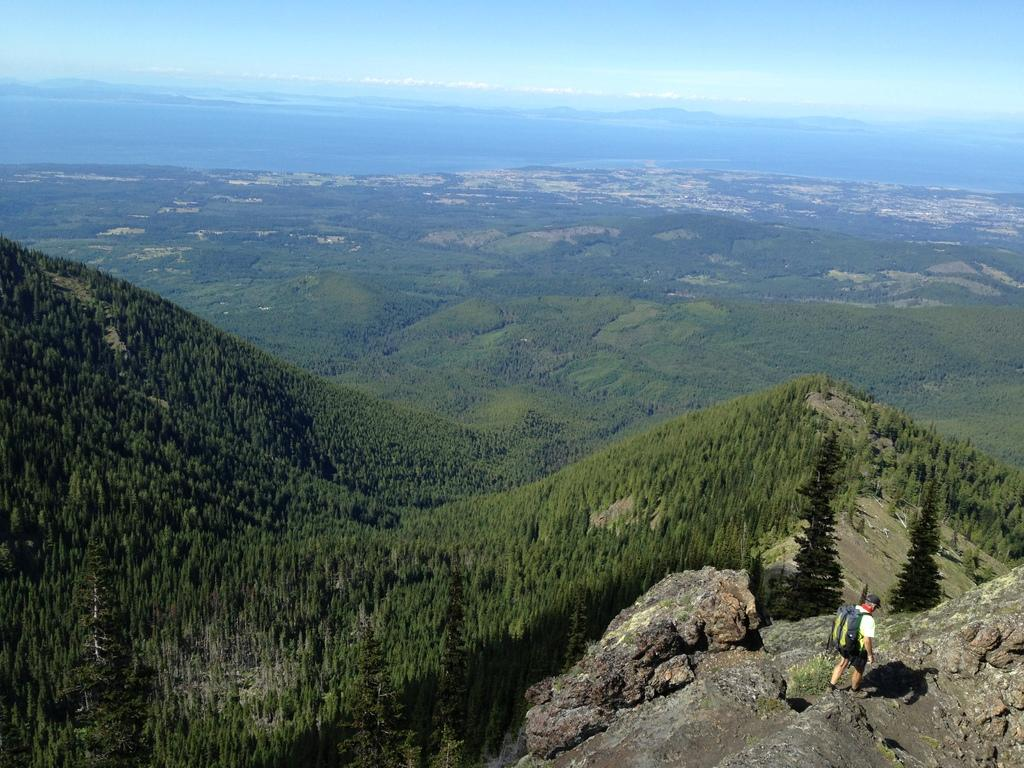What is the person in the image doing? The person is standing on a rock in the image. What type of natural environment is visible in the image? There are trees and a mountain visible in the image. What can be seen in the background of the image? The sky is visible in the background of the image. What does the taste of the rock feel like in the image? There is no information about the taste of the rock in the image, as it is a visual representation. 